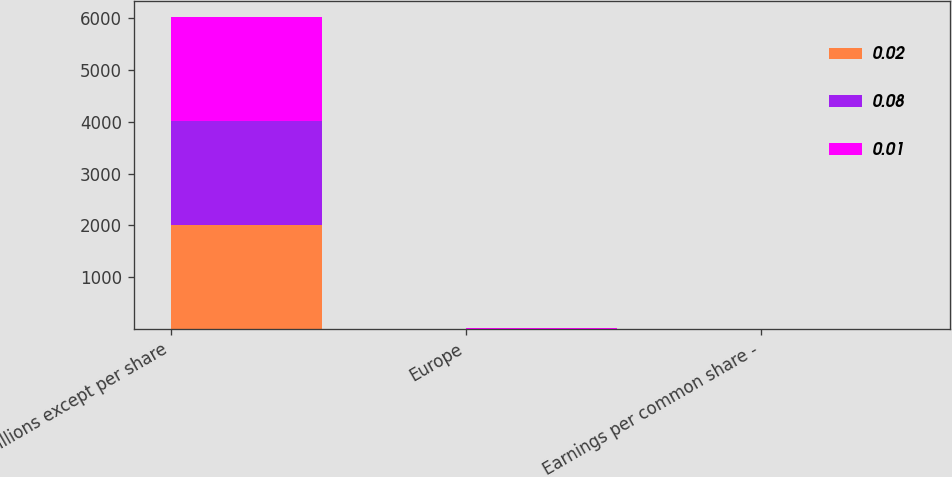Convert chart to OTSL. <chart><loc_0><loc_0><loc_500><loc_500><stacked_bar_chart><ecel><fcel>In millions except per share<fcel>Europe<fcel>Earnings per common share -<nl><fcel>0.02<fcel>2010<fcel>1<fcel>0.02<nl><fcel>0.08<fcel>2009<fcel>4<fcel>0.08<nl><fcel>0.01<fcel>2008<fcel>6<fcel>0.01<nl></chart> 